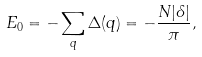Convert formula to latex. <formula><loc_0><loc_0><loc_500><loc_500>E _ { 0 } = - \sum _ { q } \Delta ( q ) = - \frac { N | \delta | } { \pi } ,</formula> 